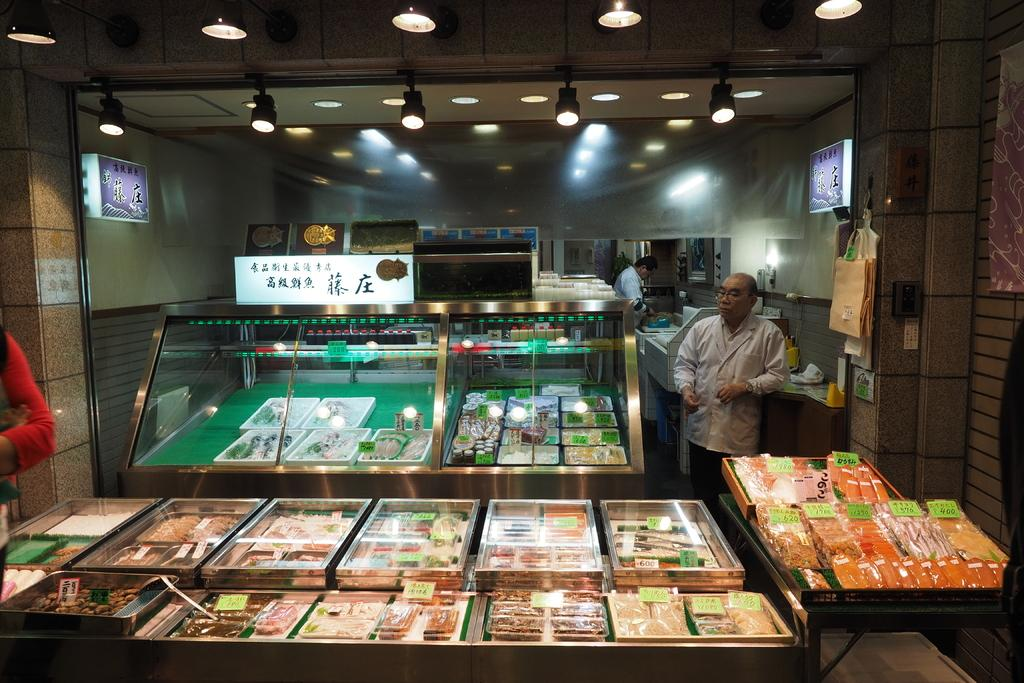What type of establishment is depicted in the image? There are food stalls in the image, suggesting it is a food market or similar venue. Can you describe the people in the image? There are people in the image, but their specific actions or characteristics are not mentioned in the provided facts. What is visible at the top of the image? There is a ceiling with lights visible at the top of the image. What appliance is being used to cook the nation's favorite dish in the image? There is no appliance or specific dish mentioned in the image, so it is not possible to answer that question. 